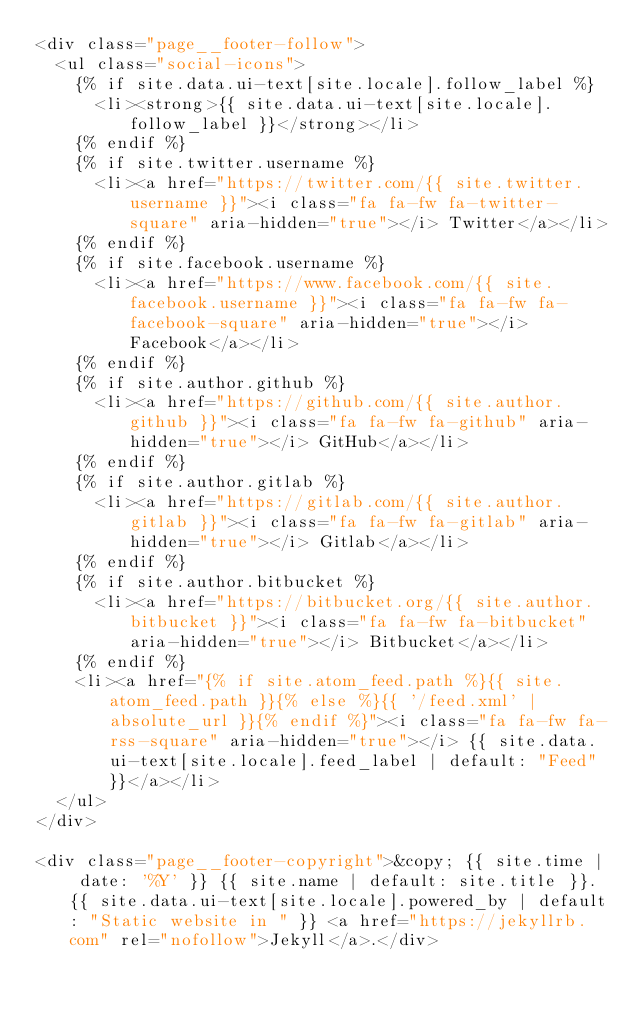Convert code to text. <code><loc_0><loc_0><loc_500><loc_500><_HTML_><div class="page__footer-follow">
  <ul class="social-icons">
    {% if site.data.ui-text[site.locale].follow_label %}
      <li><strong>{{ site.data.ui-text[site.locale].follow_label }}</strong></li>
    {% endif %}
    {% if site.twitter.username %}
      <li><a href="https://twitter.com/{{ site.twitter.username }}"><i class="fa fa-fw fa-twitter-square" aria-hidden="true"></i> Twitter</a></li>
    {% endif %}
    {% if site.facebook.username %}
      <li><a href="https://www.facebook.com/{{ site.facebook.username }}"><i class="fa fa-fw fa-facebook-square" aria-hidden="true"></i> Facebook</a></li>
    {% endif %}
    {% if site.author.github %}
      <li><a href="https://github.com/{{ site.author.github }}"><i class="fa fa-fw fa-github" aria-hidden="true"></i> GitHub</a></li>
    {% endif %}
    {% if site.author.gitlab %}
      <li><a href="https://gitlab.com/{{ site.author.gitlab }}"><i class="fa fa-fw fa-gitlab" aria-hidden="true"></i> Gitlab</a></li>
    {% endif %}
    {% if site.author.bitbucket %}
      <li><a href="https://bitbucket.org/{{ site.author.bitbucket }}"><i class="fa fa-fw fa-bitbucket" aria-hidden="true"></i> Bitbucket</a></li>
    {% endif %}
    <li><a href="{% if site.atom_feed.path %}{{ site.atom_feed.path }}{% else %}{{ '/feed.xml' | absolute_url }}{% endif %}"><i class="fa fa-fw fa-rss-square" aria-hidden="true"></i> {{ site.data.ui-text[site.locale].feed_label | default: "Feed" }}</a></li>
  </ul>
</div>

<div class="page__footer-copyright">&copy; {{ site.time | date: '%Y' }} {{ site.name | default: site.title }}. {{ site.data.ui-text[site.locale].powered_by | default: "Static website in " }} <a href="https://jekyllrb.com" rel="nofollow">Jekyll</a>.</div>
</code> 